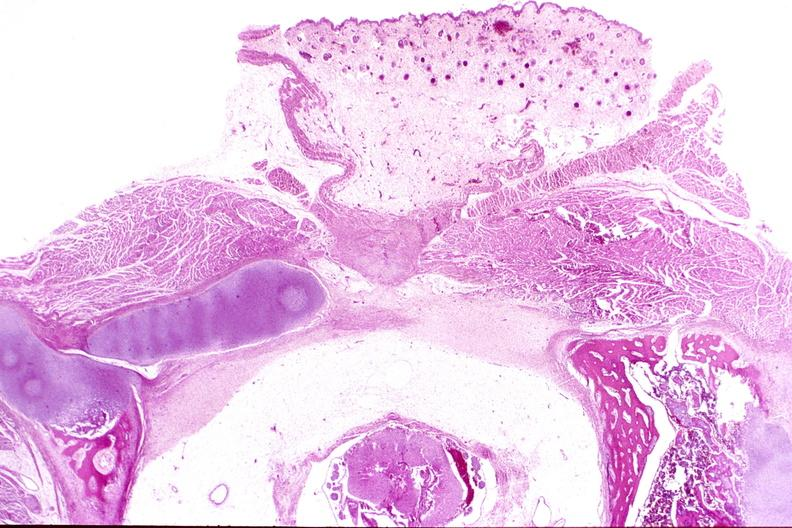where is this?
Answer the question using a single word or phrase. Nervous 